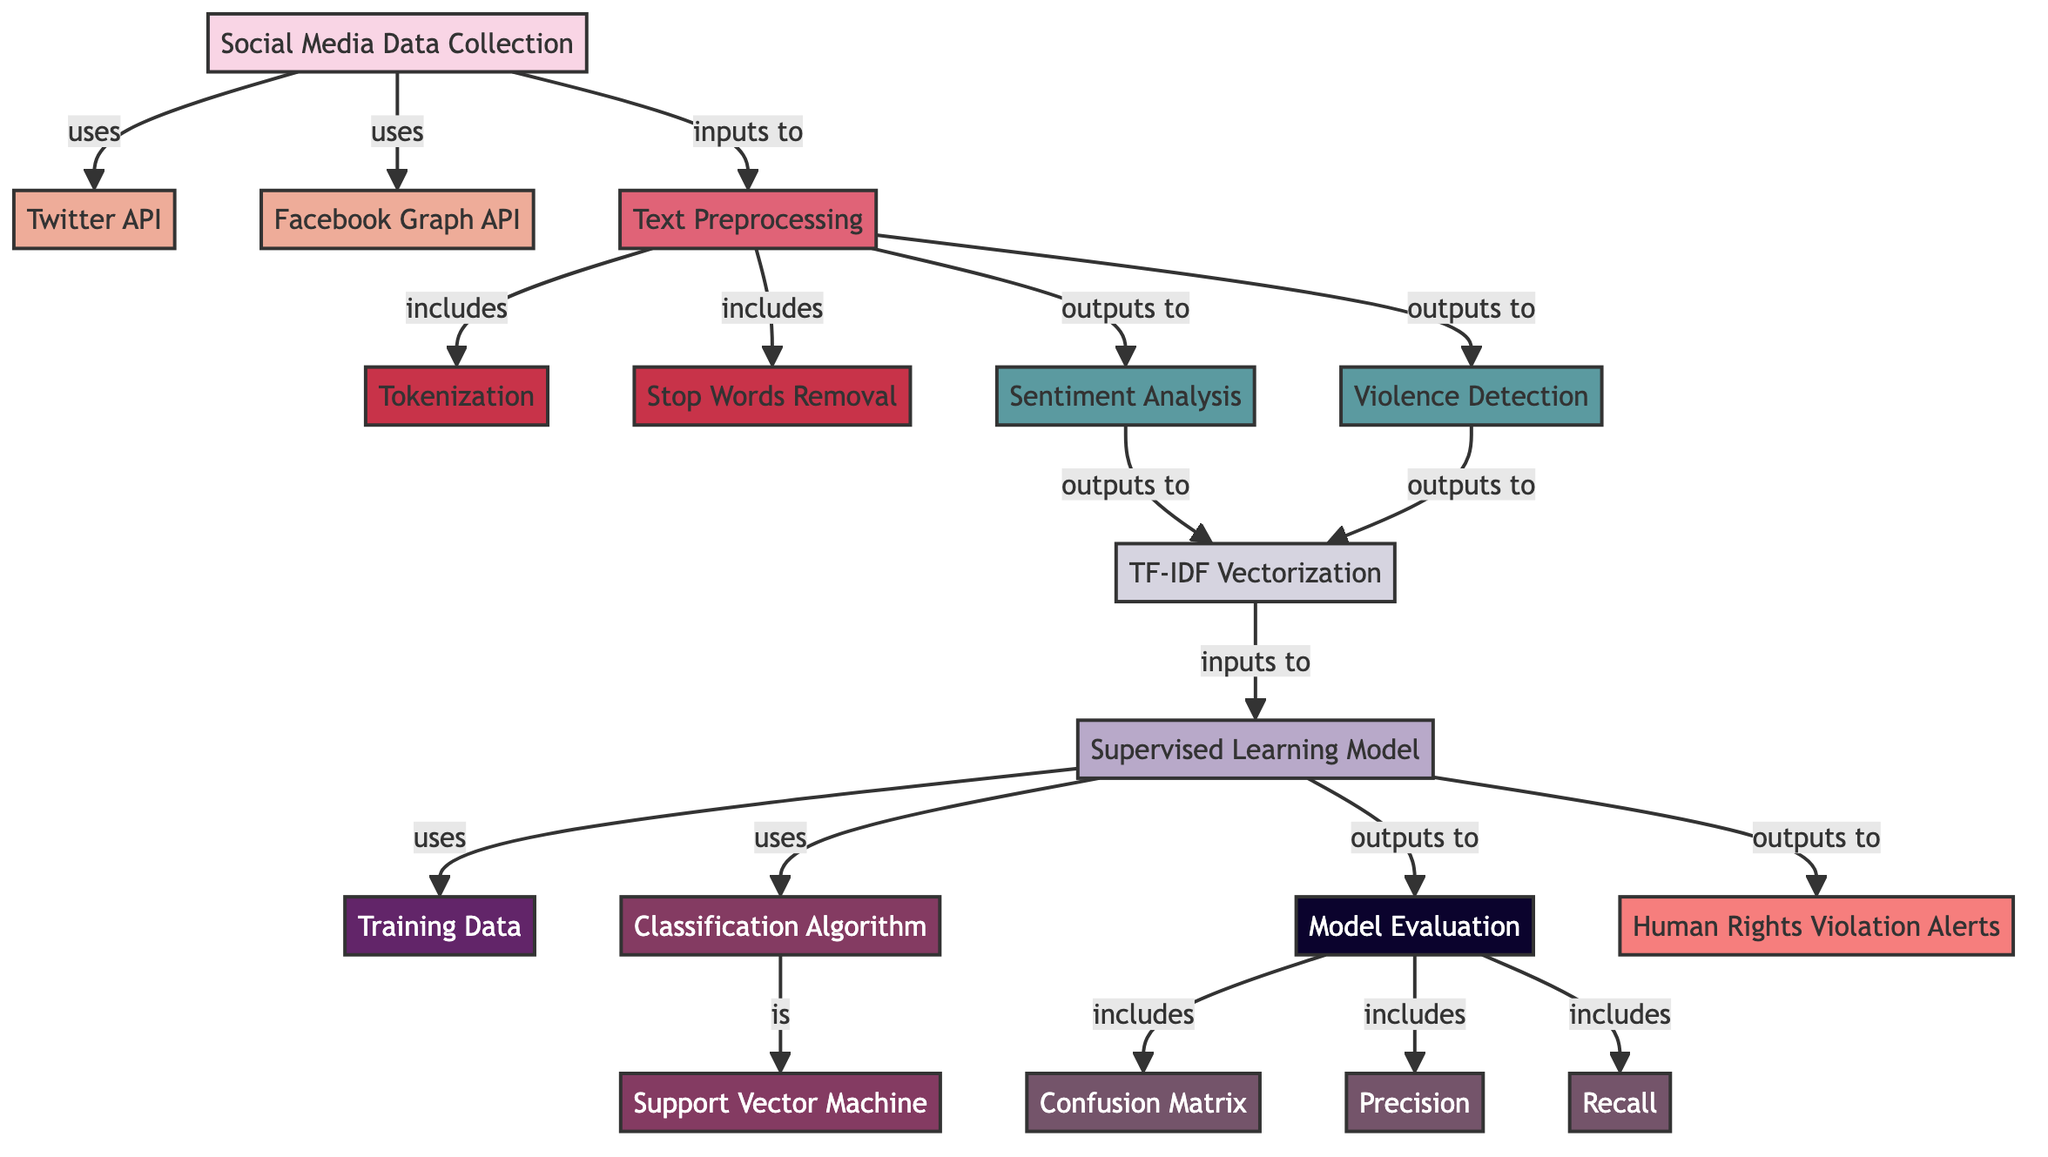What data sources are used in this diagram? The diagram indicates two data sources used for social media data collection, which are the Twitter API and the Facebook Graph API.
Answer: Twitter API, Facebook Graph API How many steps are involved in the text preprocessing phase? The text preprocessing phase includes three specific steps: Tokenization, Stop Words Removal, and Text Preprocessing itself. Therefore, there are three steps involved in total.
Answer: 3 What is the output of the Supervised Learning Model? The Supervised Learning Model outputs Human Rights Violation Alerts, which is indicated at the end of the diagram.
Answer: Human Rights Violation Alerts Which algorithm is used in the model? The diagram specifies that the classification algorithm used in the model is the Support Vector Machine.
Answer: Support Vector Machine What metrics are included in the Model Evaluation? The Model Evaluation section includes three metrics: Confusion Matrix, Precision, and Recall, indicating that these metrics are used to evaluate the model's performance.
Answer: Confusion Matrix, Precision, Recall What is the first process after collecting social media data? After the social media data is collected, the first process indicated in the diagram is Text Preprocessing. This process immediately follows data collection.
Answer: Text Preprocessing Which analyses are conducted during the processing of the data? The diagram shows two analyses that are conducted during the processing of the data: Sentiment Analysis and Violence Detection.
Answer: Sentiment Analysis, Violence Detection What does the TF-IDF Vectorization feed into? The TF-IDF Vectorization feeds into the Supervised Learning Model, which is indicated as the next step following feature extraction in the flow of the diagram.
Answer: Supervised Learning Model How many data sources are connected to social media data collection? There are two data sources (Twitter API and Facebook Graph API) connected to the Social Media Data Collection node, as indicated in the diagram.
Answer: 2 